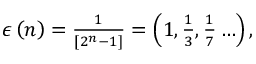<formula> <loc_0><loc_0><loc_500><loc_500>\begin{array} { r } { \epsilon \left ( n \right ) = \frac { 1 } { \left [ 2 ^ { n } - 1 \right ] } = \left ( 1 , \frac { 1 } { 3 } , \frac { 1 } { 7 } \dots \right ) , } \end{array}</formula> 